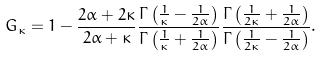Convert formula to latex. <formula><loc_0><loc_0><loc_500><loc_500>G _ { \kappa } = 1 - \frac { 2 \alpha + 2 \kappa } { 2 \alpha + \kappa } \frac { \Gamma \left ( \frac { 1 } { \kappa } - \frac { 1 } { 2 \alpha } \right ) } { \Gamma \left ( \frac { 1 } { \kappa } + \frac { 1 } { 2 \alpha } \right ) } \frac { \Gamma \left ( \frac { 1 } { 2 \kappa } + \frac { 1 } { 2 \alpha } \right ) } { \Gamma \left ( \frac { 1 } { 2 \kappa } - \frac { 1 } { 2 \alpha } \right ) } .</formula> 